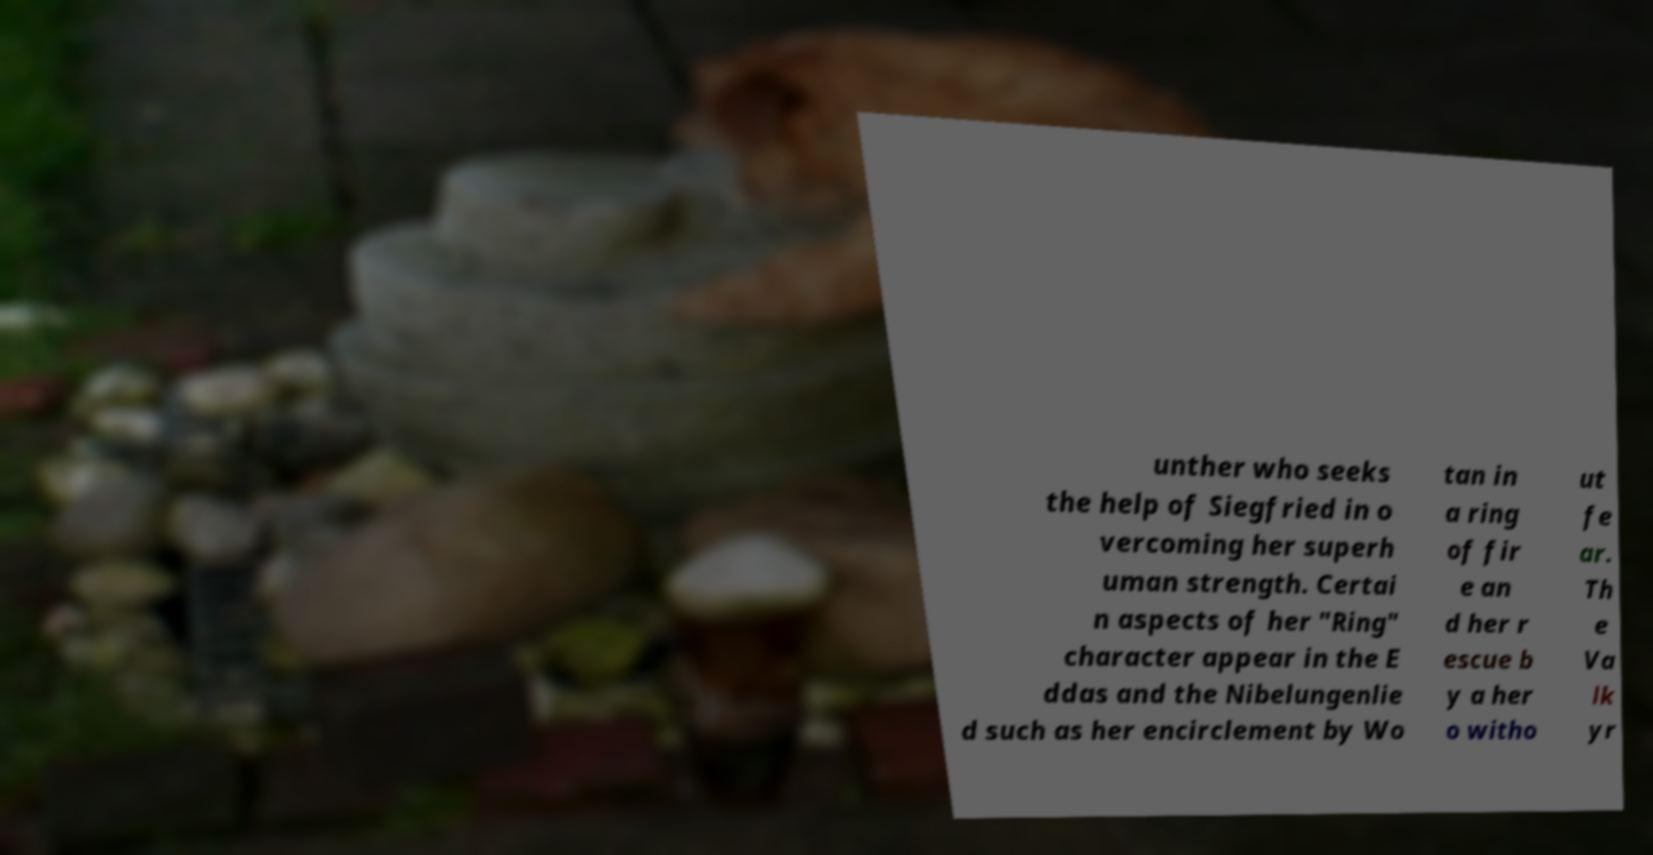Can you accurately transcribe the text from the provided image for me? unther who seeks the help of Siegfried in o vercoming her superh uman strength. Certai n aspects of her "Ring" character appear in the E ddas and the Nibelungenlie d such as her encirclement by Wo tan in a ring of fir e an d her r escue b y a her o witho ut fe ar. Th e Va lk yr 